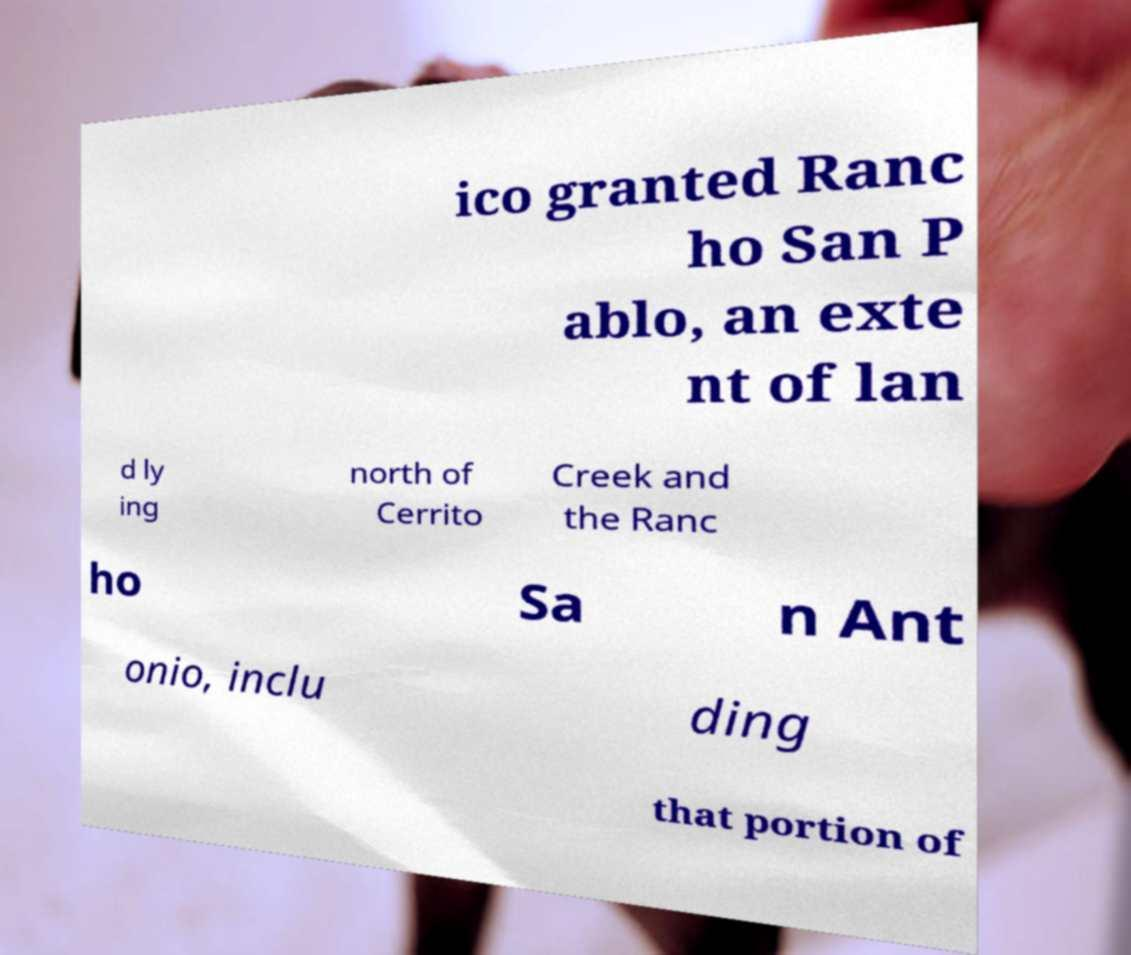I need the written content from this picture converted into text. Can you do that? ico granted Ranc ho San P ablo, an exte nt of lan d ly ing north of Cerrito Creek and the Ranc ho Sa n Ant onio, inclu ding that portion of 